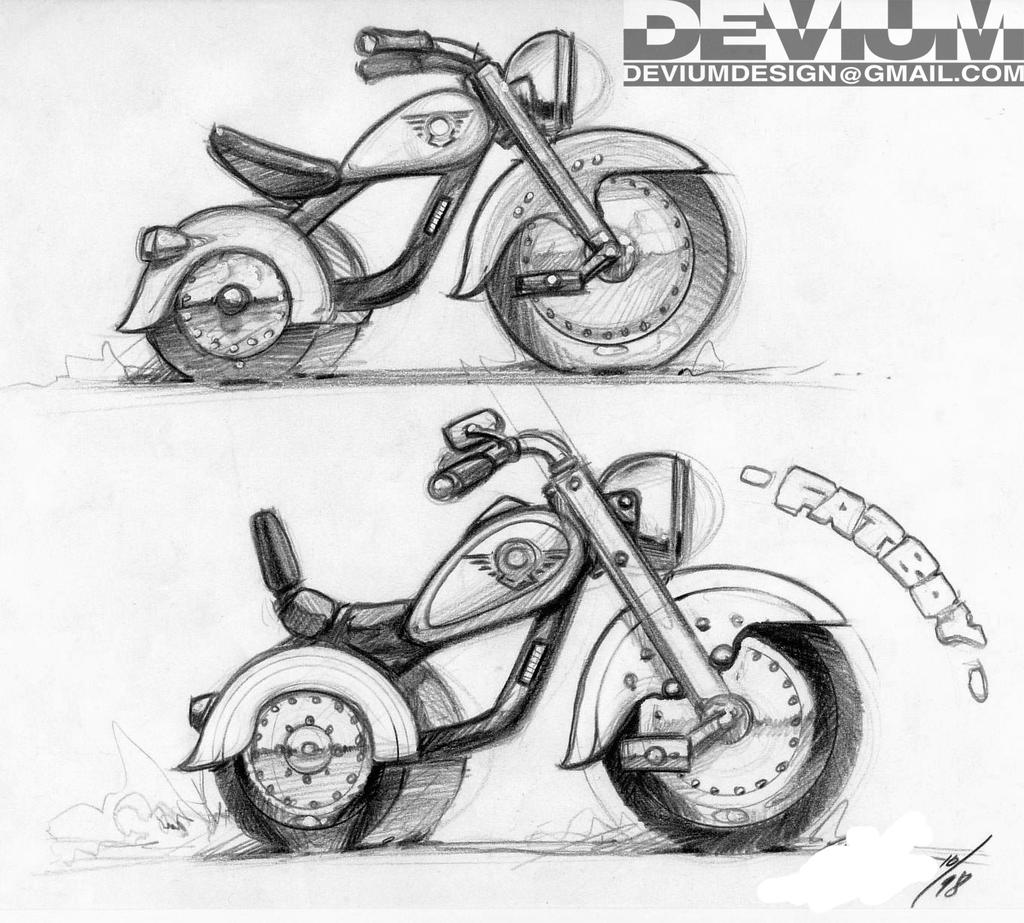What type of drawing is shown in the image? The image is a pencil drawing. What subjects are depicted in the drawing? There are two motorcycles depicted in the drawing. How many quarters are placed on the motorcycles in the image? There are no quarters present in the image; it is a pencil drawing of two motorcycles. 